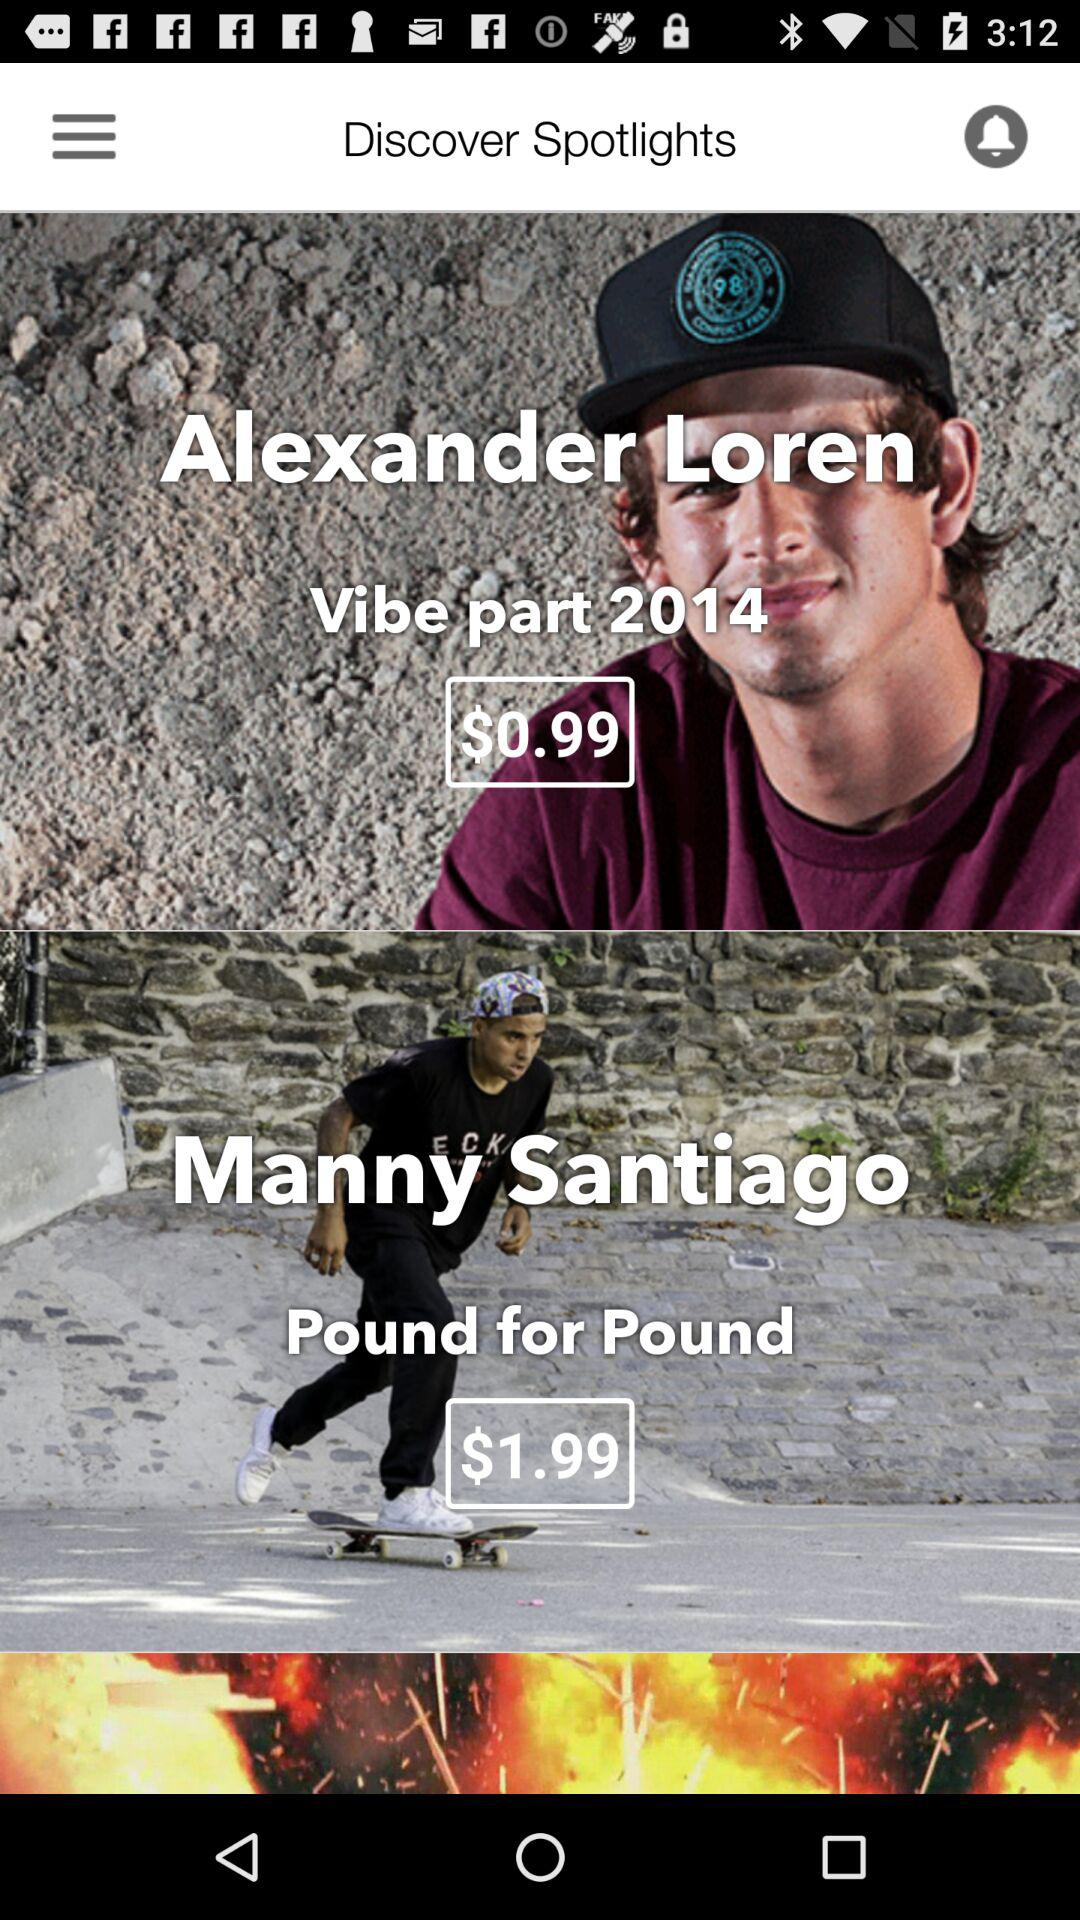What is the price mentioned for Manny Santiago's "Pound for Pound"? The price mentioned for Manny Santiago's "Pound for Pound" is $1.99. 